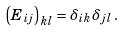<formula> <loc_0><loc_0><loc_500><loc_500>\left ( E _ { i j } \right ) _ { k l } = \delta _ { i k } \delta _ { j l } \, .</formula> 